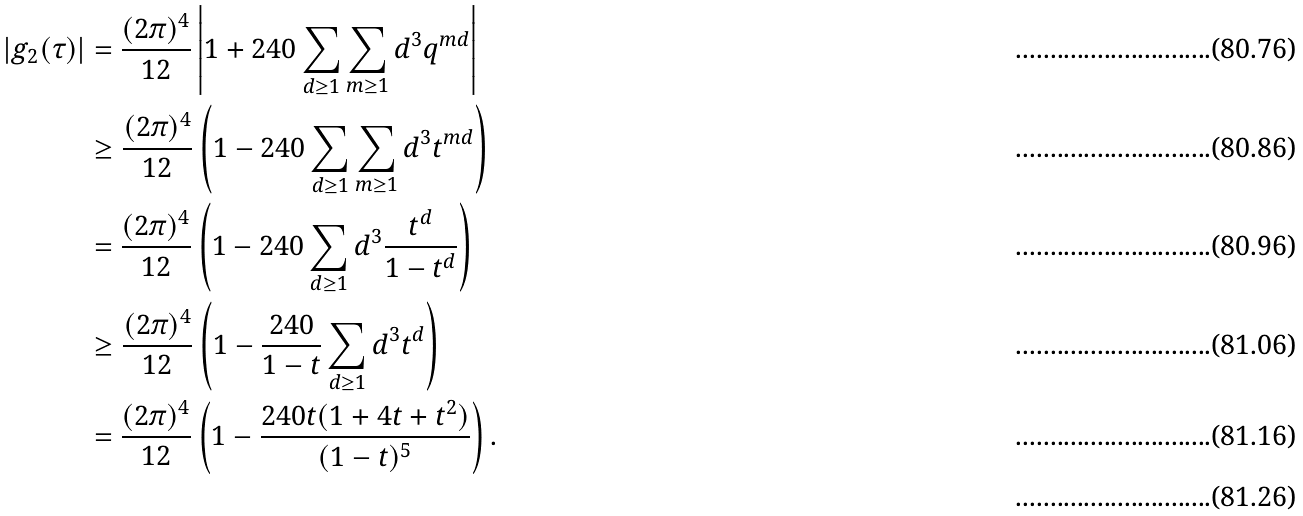Convert formula to latex. <formula><loc_0><loc_0><loc_500><loc_500>| g _ { 2 } ( \tau ) | & = \frac { ( 2 \pi ) ^ { 4 } } { 1 2 } \left | 1 + 2 4 0 \sum _ { d \geq 1 } \sum _ { m \geq 1 } d ^ { 3 } q ^ { m d } \right | \\ & \geq \frac { ( 2 \pi ) ^ { 4 } } { 1 2 } \left ( 1 - 2 4 0 \sum _ { d \geq 1 } \sum _ { m \geq 1 } d ^ { 3 } t ^ { m d } \right ) \\ & = \frac { ( 2 \pi ) ^ { 4 } } { 1 2 } \left ( 1 - 2 4 0 \sum _ { d \geq 1 } d ^ { 3 } \frac { t ^ { d } } { 1 - t ^ { d } } \right ) \\ & \geq \frac { ( 2 \pi ) ^ { 4 } } { 1 2 } \left ( 1 - \frac { 2 4 0 } { 1 - t } \sum _ { d \geq 1 } d ^ { 3 } t ^ { d } \right ) \\ & = \frac { ( 2 \pi ) ^ { 4 } } { 1 2 } \left ( 1 - \frac { 2 4 0 t ( 1 + 4 t + t ^ { 2 } ) } { ( 1 - t ) ^ { 5 } } \right ) . \\</formula> 